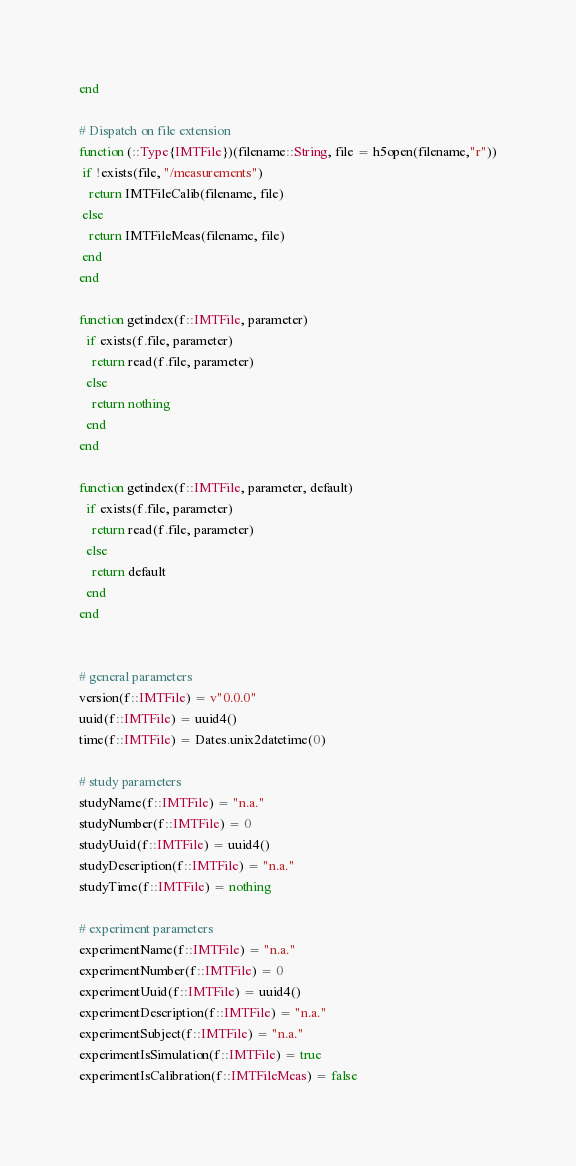Convert code to text. <code><loc_0><loc_0><loc_500><loc_500><_Julia_>end

# Dispatch on file extension
function (::Type{IMTFile})(filename::String, file = h5open(filename,"r"))
 if !exists(file, "/measurements")
   return IMTFileCalib(filename, file)
 else
   return IMTFileMeas(filename, file)
 end
end

function getindex(f::IMTFile, parameter)
  if exists(f.file, parameter)
    return read(f.file, parameter)
  else
    return nothing
  end
end

function getindex(f::IMTFile, parameter, default)
  if exists(f.file, parameter)
    return read(f.file, parameter)
  else
    return default
  end
end


# general parameters
version(f::IMTFile) = v"0.0.0"
uuid(f::IMTFile) = uuid4()
time(f::IMTFile) = Dates.unix2datetime(0)

# study parameters
studyName(f::IMTFile) = "n.a."
studyNumber(f::IMTFile) = 0
studyUuid(f::IMTFile) = uuid4()
studyDescription(f::IMTFile) = "n.a."
studyTime(f::IMTFile) = nothing

# experiment parameters
experimentName(f::IMTFile) = "n.a."
experimentNumber(f::IMTFile) = 0
experimentUuid(f::IMTFile) = uuid4()
experimentDescription(f::IMTFile) = "n.a."
experimentSubject(f::IMTFile) = "n.a."
experimentIsSimulation(f::IMTFile) = true
experimentIsCalibration(f::IMTFileMeas) = false</code> 